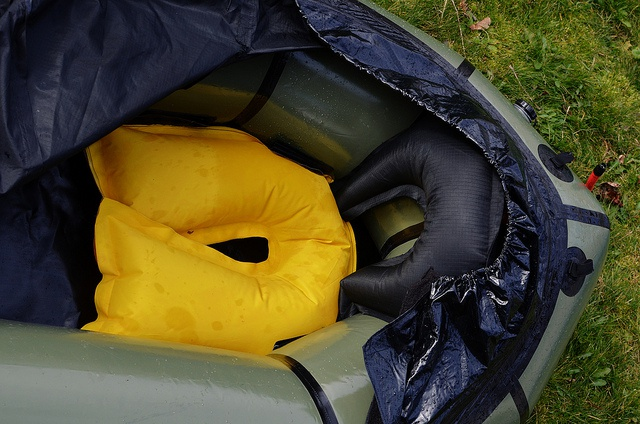Describe the objects in this image and their specific colors. I can see a boat in black, gray, and orange tones in this image. 